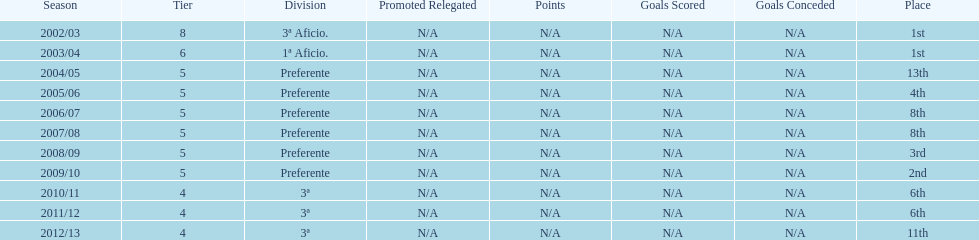In what year did the team achieve the same place as 2010/11? 2011/12. 